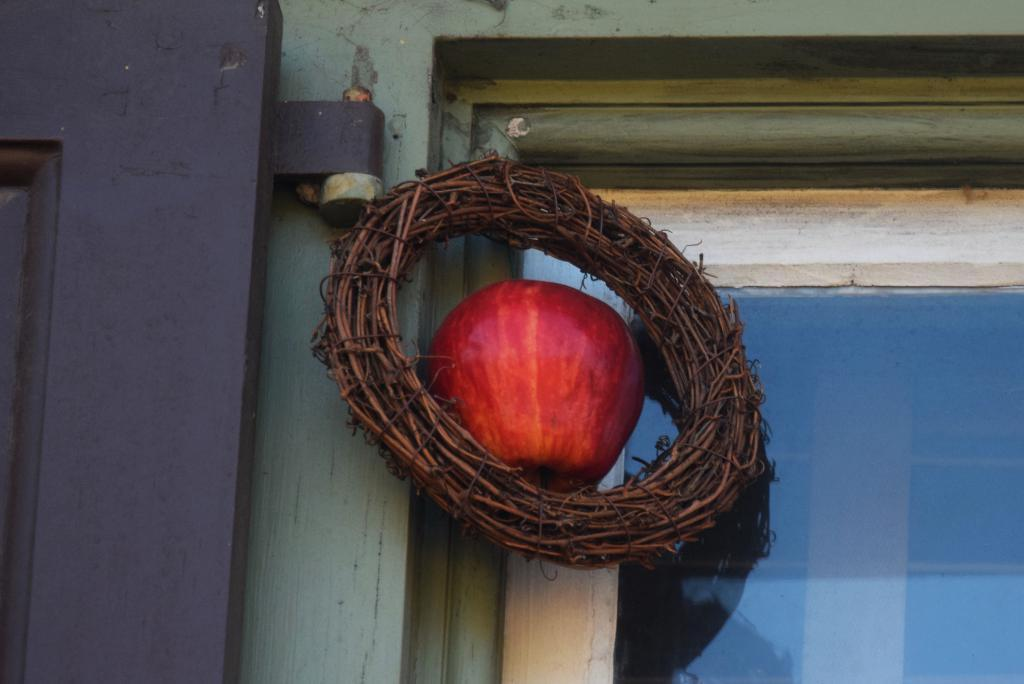What is the main object in the center of the image? There is an apple in the middle of the image. What surrounds the apple in the image? There is a wreath around the apple. What type of architectural feature can be seen on the right side of the image? There is a glass window on the right side of the image. What type of entrance is visible on the left side of the image? There appears to be a door on the left side of the image. How does the apple contribute to the knowledge of the people in the image? The image does not show any people, and the apple's presence does not contribute to any knowledge. Is there a calculator visible in the image? No, there is no calculator present in the image. 